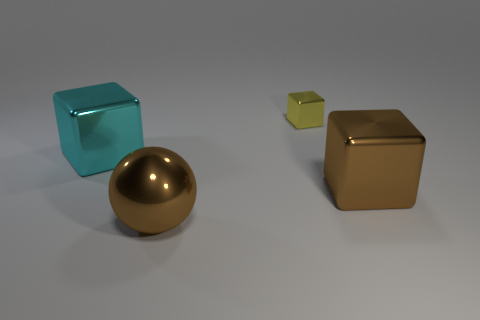Are there fewer large brown metallic cubes that are in front of the big ball than big cyan things? Yes, there are fewer large brown metallic cubes in front of the big ball compared to the number of large cyan objects. Specifically, there are two brown metallic cubes and one large cyan cube visible. 